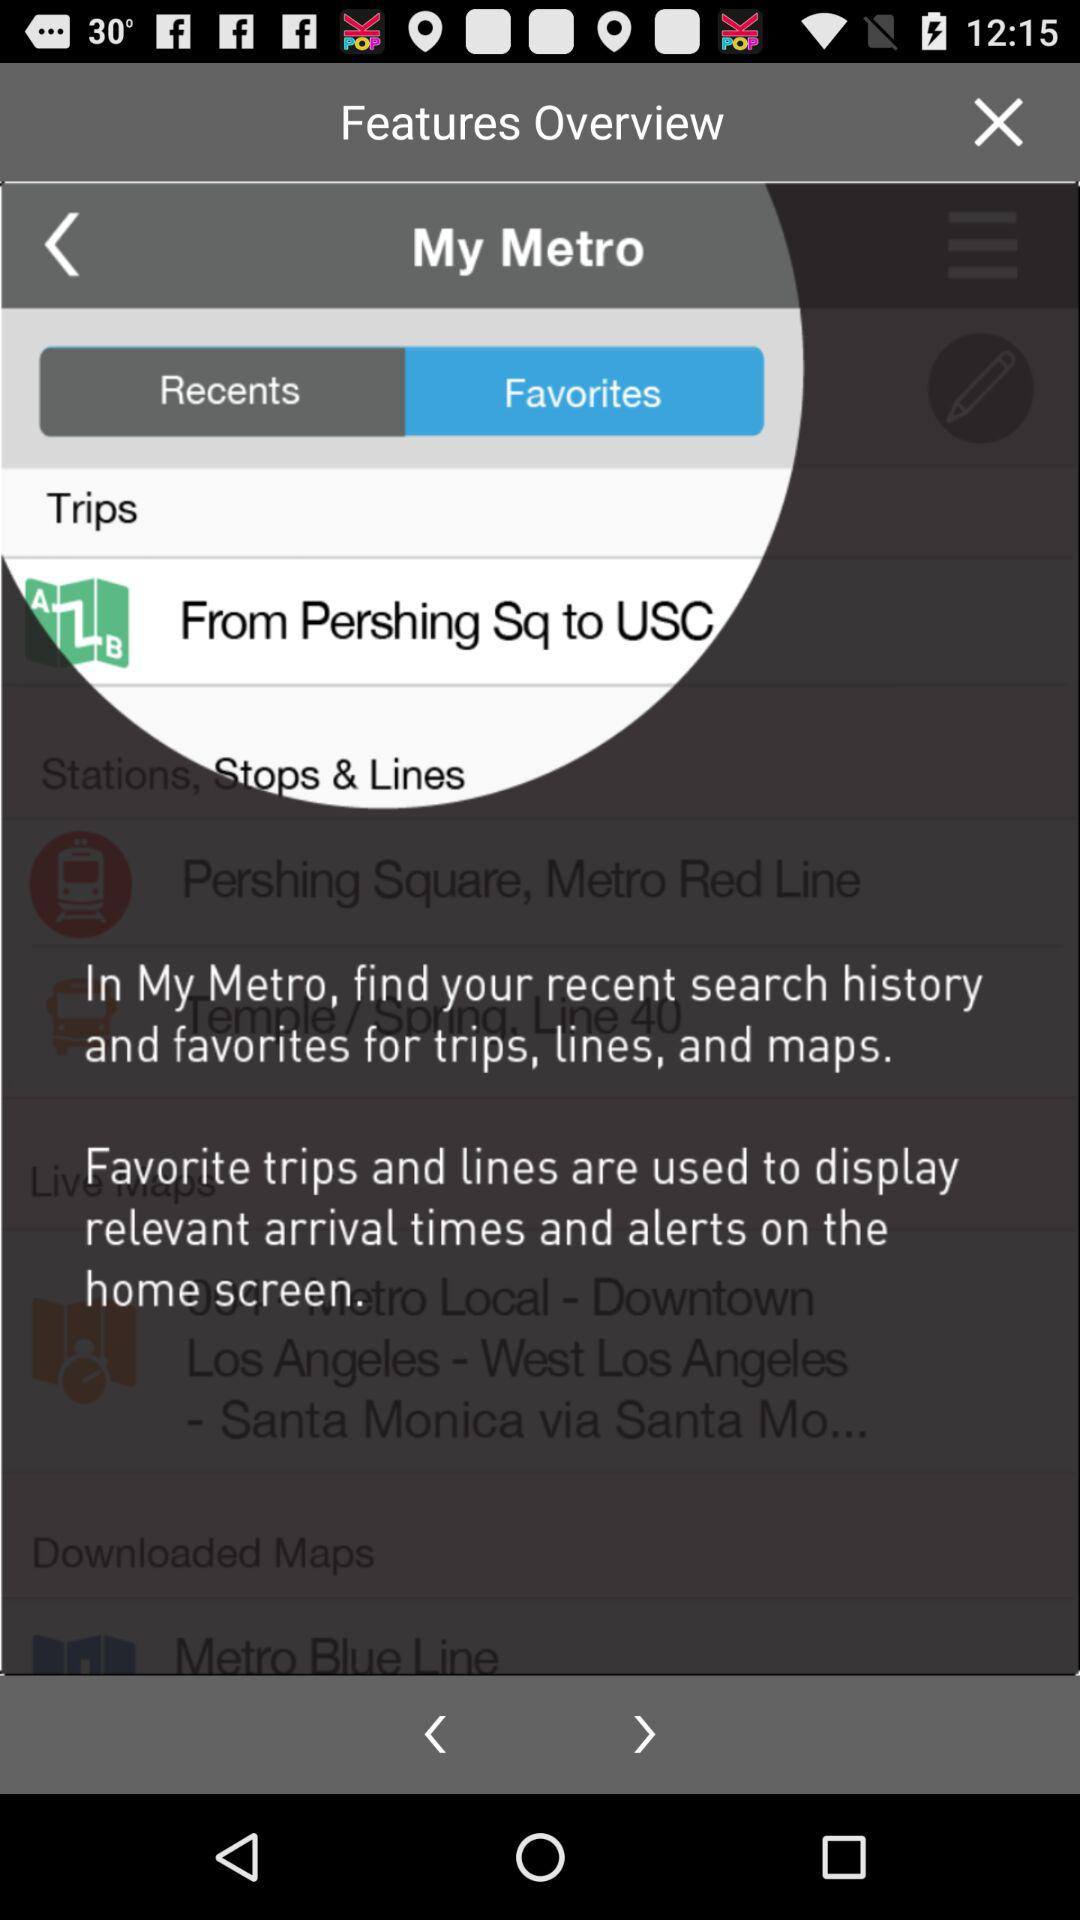How many items are in "Recents"?
When the provided information is insufficient, respond with <no answer>. <no answer> 